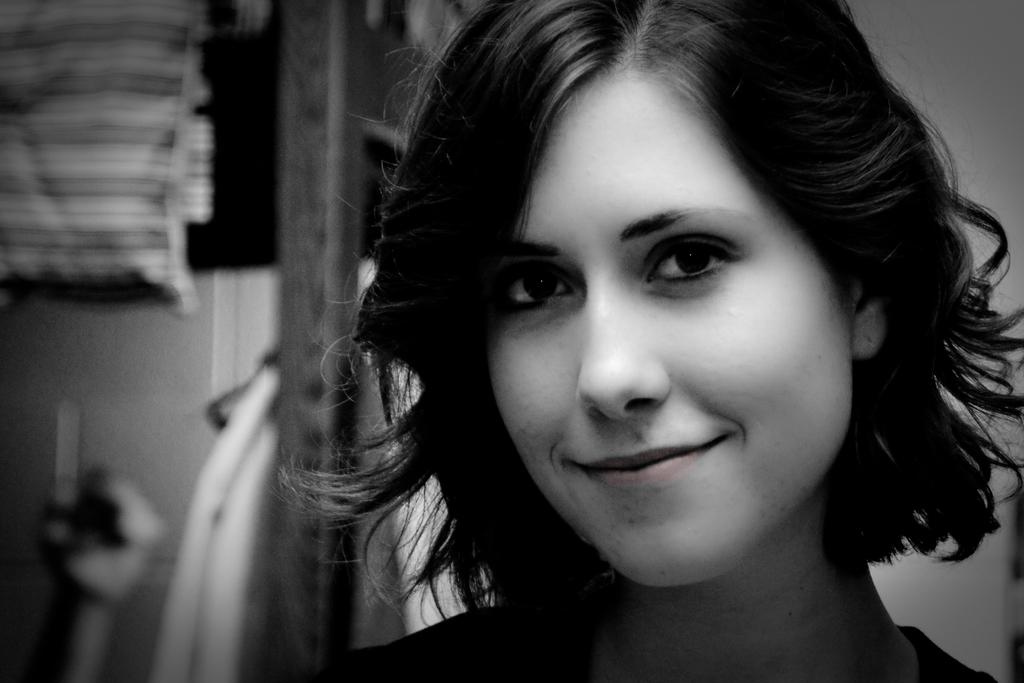What is the main subject of the image? There is a person in the image. Can you describe the background of the image? The background of the image is blurred. What type of advertisement can be seen in the background of the image? There is no advertisement present in the image; the background is blurred. How does the fog affect the visibility of the mailbox in the image? There is no mailbox present in the image, and the background is blurred, not foggy. 